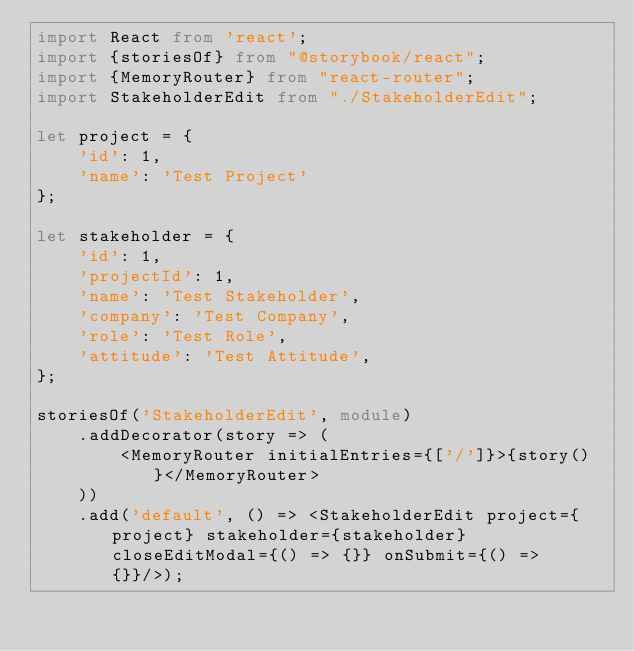Convert code to text. <code><loc_0><loc_0><loc_500><loc_500><_TypeScript_>import React from 'react';
import {storiesOf} from "@storybook/react";
import {MemoryRouter} from "react-router";
import StakeholderEdit from "./StakeholderEdit";

let project = {
    'id': 1,
    'name': 'Test Project'
};

let stakeholder = {
    'id': 1,
    'projectId': 1,
    'name': 'Test Stakeholder',
    'company': 'Test Company',
    'role': 'Test Role',
    'attitude': 'Test Attitude',
};

storiesOf('StakeholderEdit', module)
    .addDecorator(story => (
        <MemoryRouter initialEntries={['/']}>{story()}</MemoryRouter>
    ))
    .add('default', () => <StakeholderEdit project={project} stakeholder={stakeholder} closeEditModal={() => {}} onSubmit={() => {}}/>);
</code> 